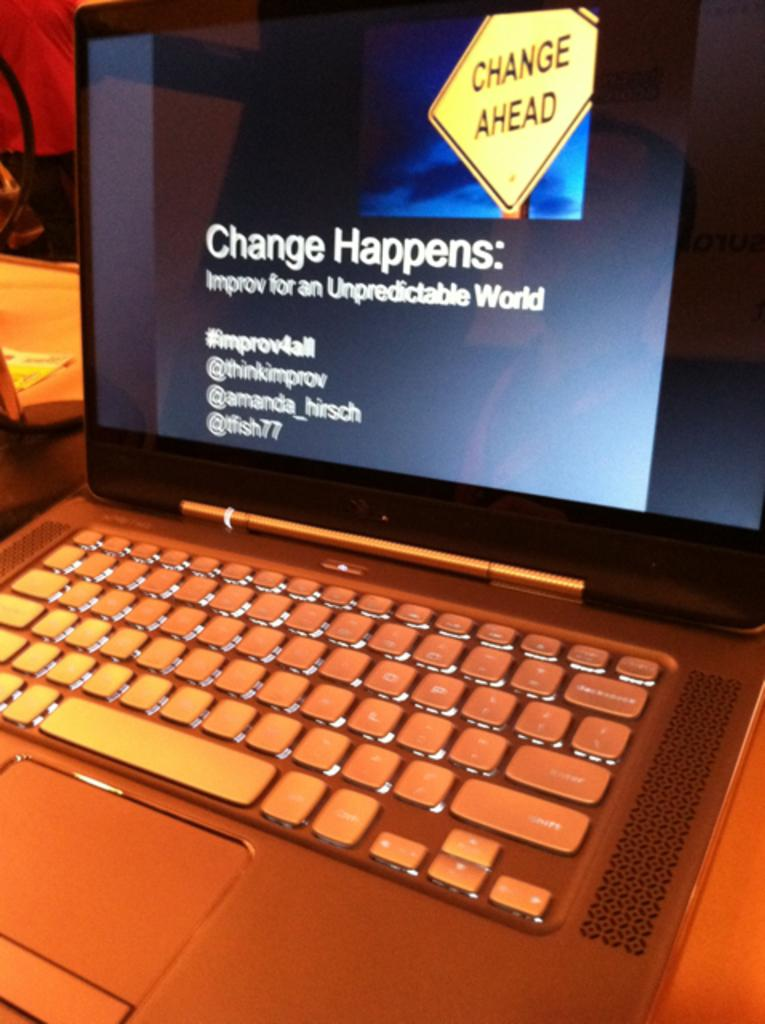Provide a one-sentence caption for the provided image. The screen of a laptop computer displays information about change. 